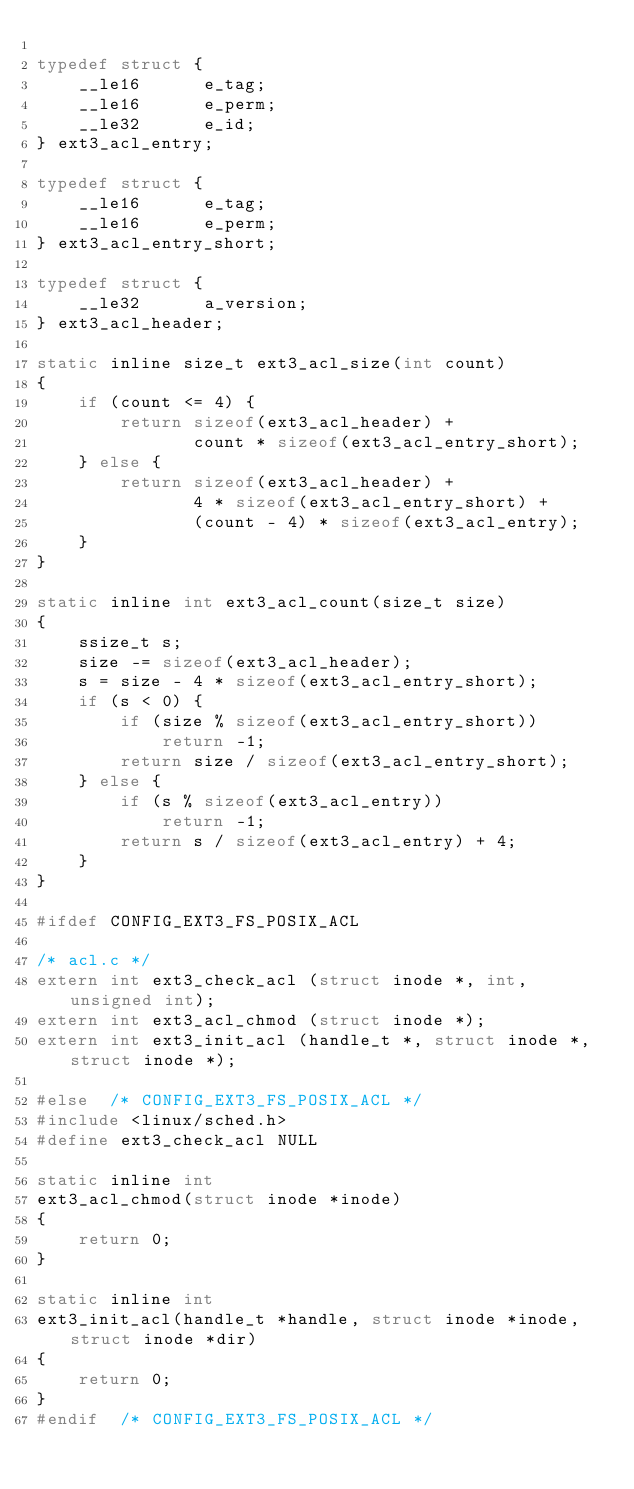Convert code to text. <code><loc_0><loc_0><loc_500><loc_500><_C_>
typedef struct {
	__le16		e_tag;
	__le16		e_perm;
	__le32		e_id;
} ext3_acl_entry;

typedef struct {
	__le16		e_tag;
	__le16		e_perm;
} ext3_acl_entry_short;

typedef struct {
	__le32		a_version;
} ext3_acl_header;

static inline size_t ext3_acl_size(int count)
{
	if (count <= 4) {
		return sizeof(ext3_acl_header) +
		       count * sizeof(ext3_acl_entry_short);
	} else {
		return sizeof(ext3_acl_header) +
		       4 * sizeof(ext3_acl_entry_short) +
		       (count - 4) * sizeof(ext3_acl_entry);
	}
}

static inline int ext3_acl_count(size_t size)
{
	ssize_t s;
	size -= sizeof(ext3_acl_header);
	s = size - 4 * sizeof(ext3_acl_entry_short);
	if (s < 0) {
		if (size % sizeof(ext3_acl_entry_short))
			return -1;
		return size / sizeof(ext3_acl_entry_short);
	} else {
		if (s % sizeof(ext3_acl_entry))
			return -1;
		return s / sizeof(ext3_acl_entry) + 4;
	}
}

#ifdef CONFIG_EXT3_FS_POSIX_ACL

/* acl.c */
extern int ext3_check_acl (struct inode *, int, unsigned int);
extern int ext3_acl_chmod (struct inode *);
extern int ext3_init_acl (handle_t *, struct inode *, struct inode *);

#else  /* CONFIG_EXT3_FS_POSIX_ACL */
#include <linux/sched.h>
#define ext3_check_acl NULL

static inline int
ext3_acl_chmod(struct inode *inode)
{
	return 0;
}

static inline int
ext3_init_acl(handle_t *handle, struct inode *inode, struct inode *dir)
{
	return 0;
}
#endif  /* CONFIG_EXT3_FS_POSIX_ACL */
</code> 